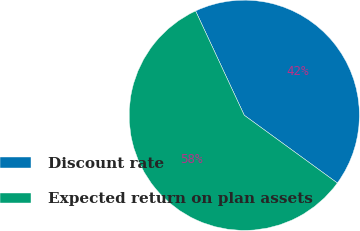Convert chart to OTSL. <chart><loc_0><loc_0><loc_500><loc_500><pie_chart><fcel>Discount rate<fcel>Expected return on plan assets<nl><fcel>41.96%<fcel>58.04%<nl></chart> 